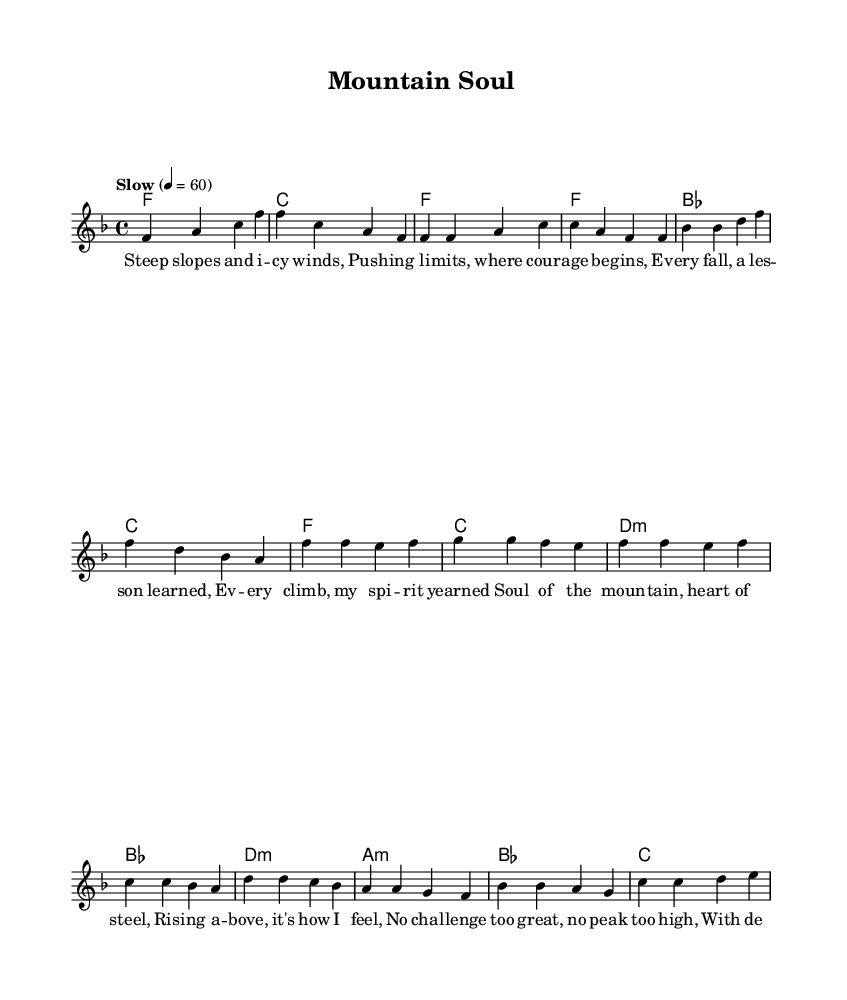What is the key signature of this music? The key signature is F major, which has one flat (B flat). This can be determined from the beginning of the score where the key is indicated.
Answer: F major What is the time signature of the piece? The time signature is 4/4, as seen at the beginning of the score. This means there are four beats per measure and the quarter note gets one beat.
Answer: 4/4 What is the tempo marking provided? The tempo marking is "Slow" with a metronome marking of 60 beats per minute. This is indicated in the tempo section of the score.
Answer: Slow, 60 How many measures are there in the verse? The verse consists of four measures, which can be counted from the melody section where the verse lyrics align with the music.
Answer: Four What is the first lyric line of the chorus? The first lyric line of the chorus is "Soul of the mountain, heart of steel." This is found under the chorus section in the lyric mode.
Answer: Soul of the mountain, heart of steel What type of musical form is primarily used in this piece? The piece primarily uses a verse-chorus form, alternating between verse and chorus sections as indicated in the structure of the lyrics.
Answer: Verse-chorus How do the lyrics reflect the theme of resilience? The lyrics describe themes of overcoming challenges and determination, as seen in phrases like "No challenge too great, no peak too high." This indicates a message of persistence and strength.
Answer: Resilience through determination 